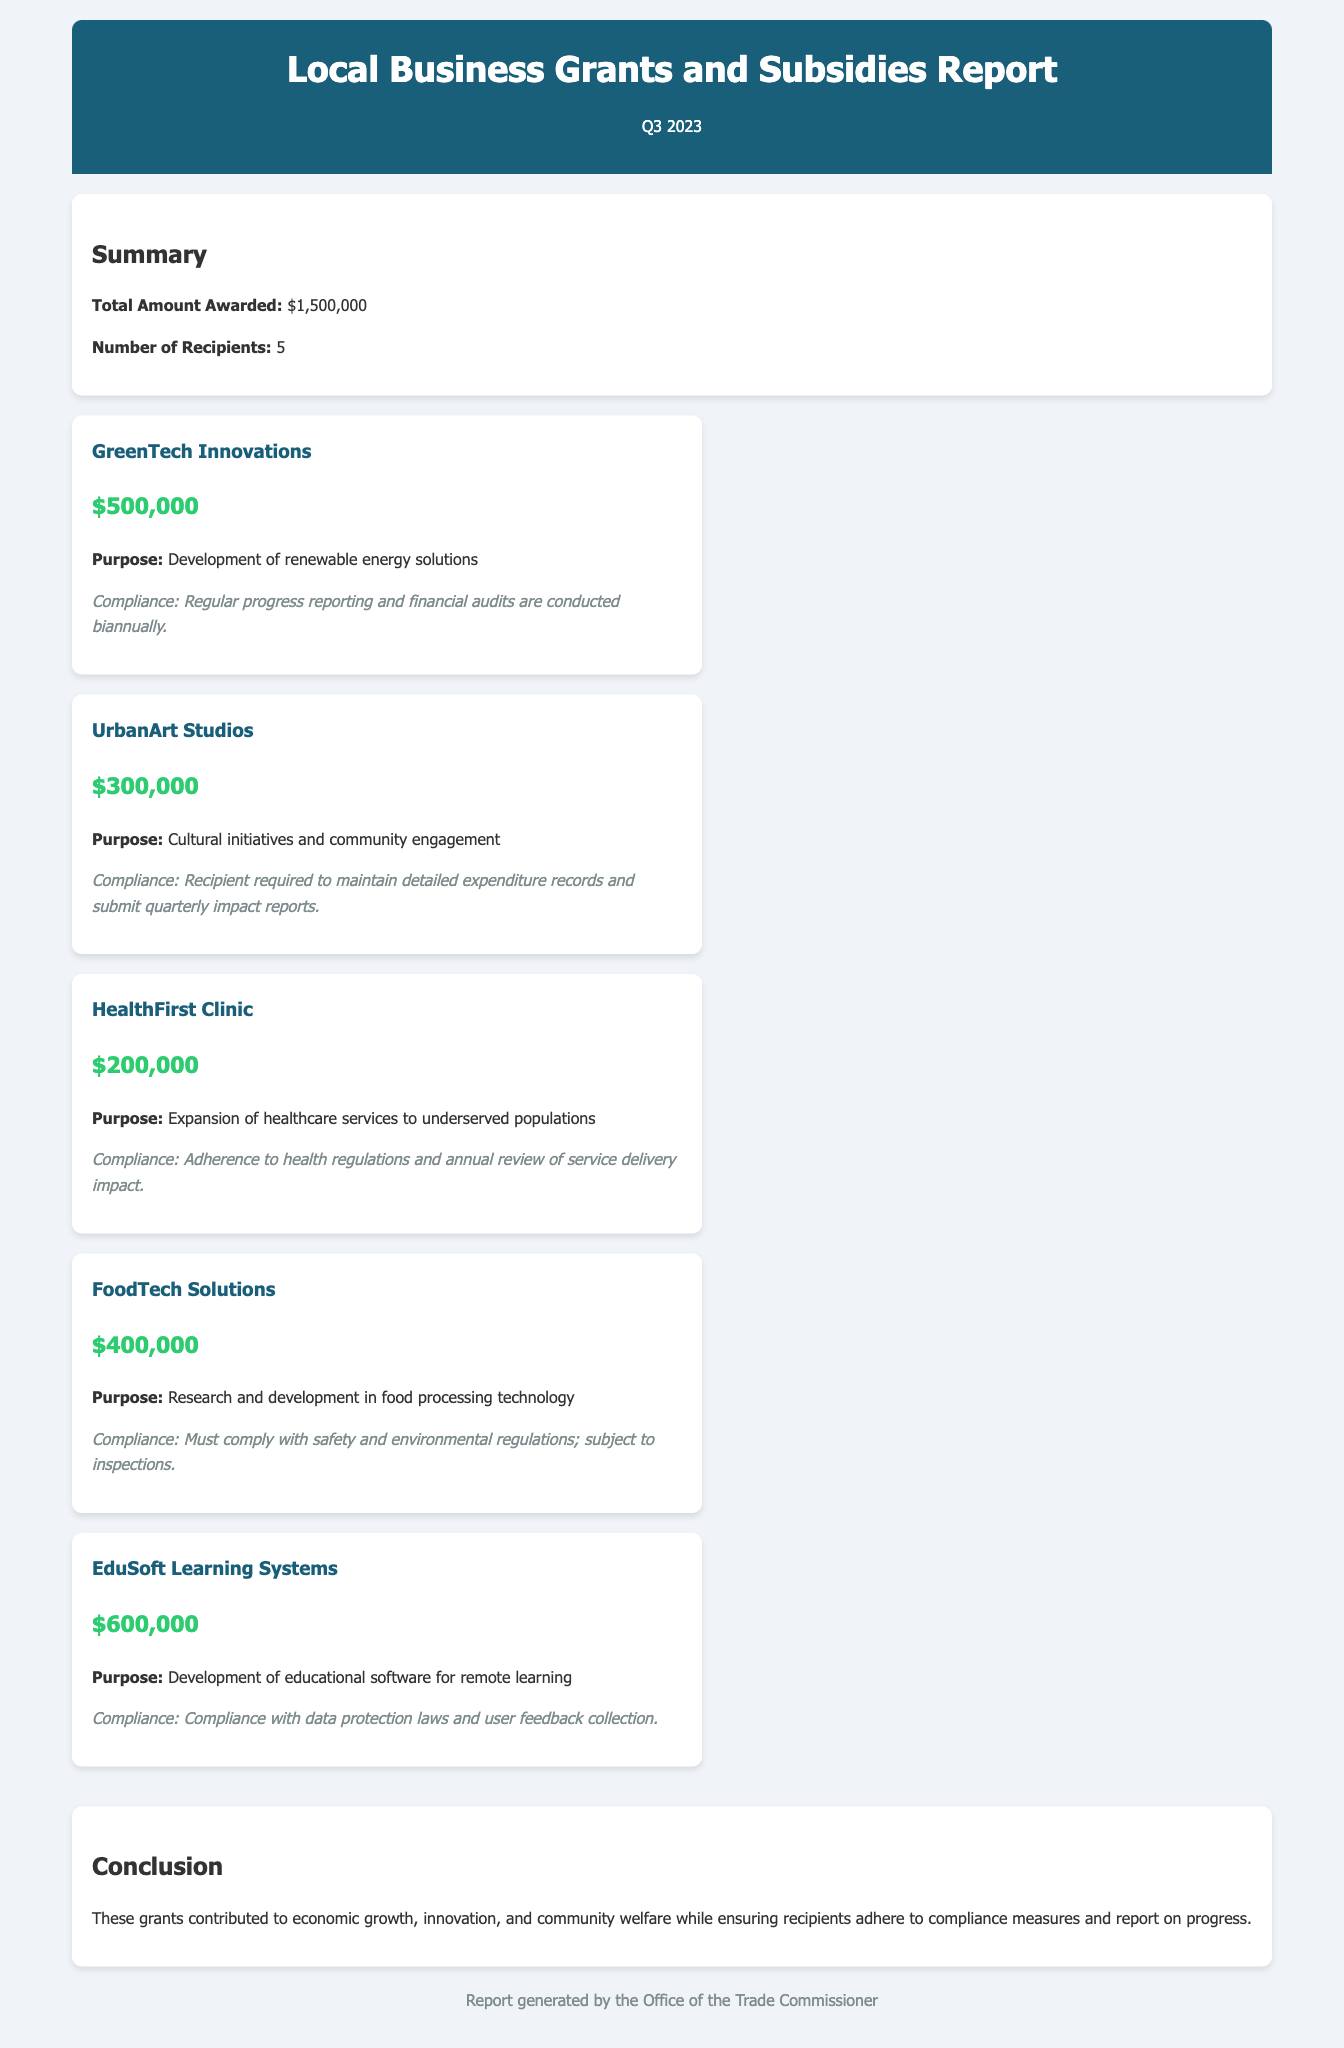what is the total amount awarded? The total amount awarded is a summary number presented in the report, which is $1,500,000.
Answer: $1,500,000 how many recipients received funding? The number of recipients is specified in the summary section of the report, which states there are 5 recipients.
Answer: 5 what is the purpose of the funding awarded to GreenTech Innovations? The purpose of the funding is indicated under the details of the grant, which mentions "Development of renewable energy solutions."
Answer: Development of renewable energy solutions which grant received the highest amount? By comparing the awarded amounts, it is clear that EduSoft Learning Systems received the highest amount of $600,000.
Answer: EduSoft Learning Systems what compliance measure is required for UrbanArt Studios? The compliance measures for UrbanArt Studios involve maintaining records, as stated in the compliance section of that grant: "Recipient required to maintain detailed expenditure records and submit quarterly impact reports."
Answer: Detailed expenditure records and quarterly impact reports what was the purpose of funding for HealthFirst Clinic? The purpose of the funding for HealthFirst Clinic is written in the report as "Expansion of healthcare services to underserved populations."
Answer: Expansion of healthcare services to underserved populations how much funding was awarded to FoodTech Solutions? The amount of funding for FoodTech Solutions is clearly stated in their grant details, which is $400,000.
Answer: $400,000 what kind of innovative development is EduSoft Learning Systems focused on? The focus of EduSoft Learning Systems' development is specified as related to "educational software for remote learning."
Answer: Educational software for remote learning what is the total financial amount awarded specifically for research and development? The totals for research and development can be calculated based on the grants, which includes FoodTech Solutions' $400,000 and GreenTech Innovations' $500,000, summing up to $900,000.
Answer: $900,000 